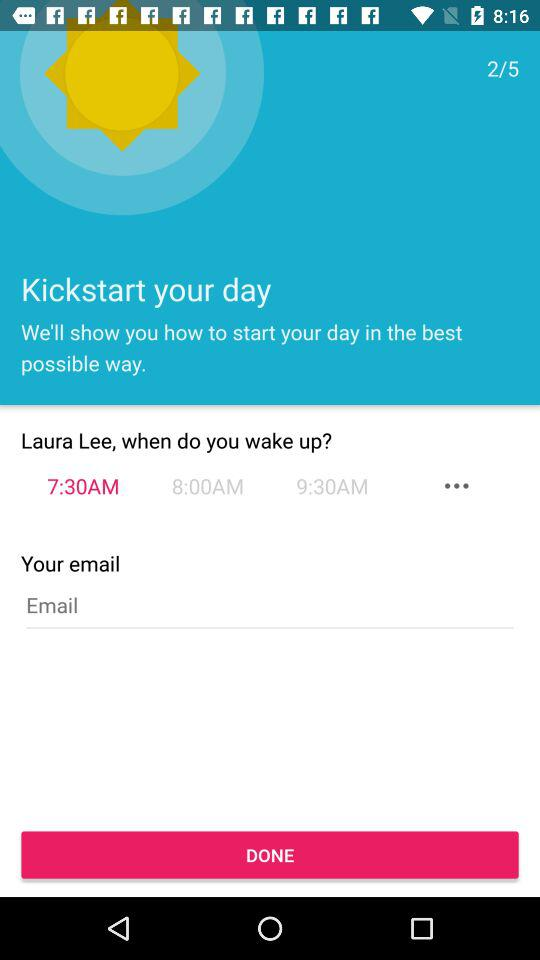What is the total number of steps? The total number of steps is 5. 